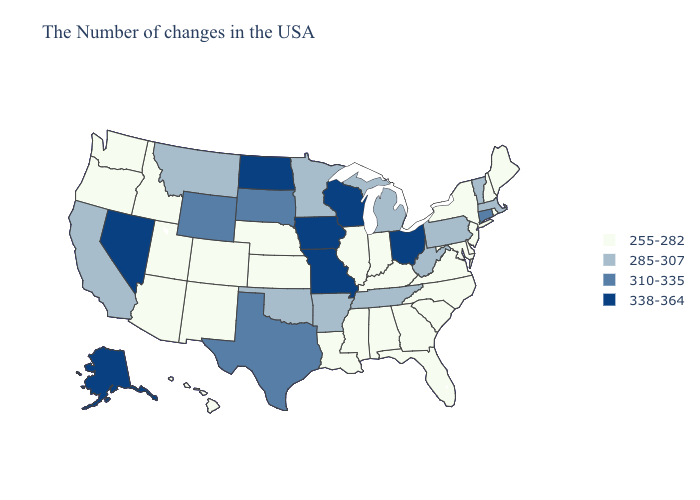Name the states that have a value in the range 255-282?
Short answer required. Maine, Rhode Island, New Hampshire, New York, New Jersey, Delaware, Maryland, Virginia, North Carolina, South Carolina, Florida, Georgia, Kentucky, Indiana, Alabama, Illinois, Mississippi, Louisiana, Kansas, Nebraska, Colorado, New Mexico, Utah, Arizona, Idaho, Washington, Oregon, Hawaii. Which states have the lowest value in the USA?
Keep it brief. Maine, Rhode Island, New Hampshire, New York, New Jersey, Delaware, Maryland, Virginia, North Carolina, South Carolina, Florida, Georgia, Kentucky, Indiana, Alabama, Illinois, Mississippi, Louisiana, Kansas, Nebraska, Colorado, New Mexico, Utah, Arizona, Idaho, Washington, Oregon, Hawaii. Name the states that have a value in the range 310-335?
Keep it brief. Connecticut, Texas, South Dakota, Wyoming. What is the highest value in states that border Colorado?
Short answer required. 310-335. Among the states that border New Mexico , does Colorado have the lowest value?
Short answer required. Yes. Does Oregon have a lower value than New Hampshire?
Answer briefly. No. Which states have the lowest value in the South?
Keep it brief. Delaware, Maryland, Virginia, North Carolina, South Carolina, Florida, Georgia, Kentucky, Alabama, Mississippi, Louisiana. What is the highest value in states that border North Dakota?
Concise answer only. 310-335. Does the first symbol in the legend represent the smallest category?
Concise answer only. Yes. Among the states that border Connecticut , which have the lowest value?
Be succinct. Rhode Island, New York. Name the states that have a value in the range 338-364?
Keep it brief. Ohio, Wisconsin, Missouri, Iowa, North Dakota, Nevada, Alaska. What is the lowest value in states that border Minnesota?
Concise answer only. 310-335. Does Idaho have the lowest value in the USA?
Concise answer only. Yes. Does Florida have a lower value than Vermont?
Quick response, please. Yes. What is the value of Idaho?
Concise answer only. 255-282. 